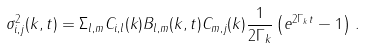<formula> <loc_0><loc_0><loc_500><loc_500>\sigma ^ { 2 } _ { i , j } ( k , t ) = \Sigma _ { l , m } C _ { i , l } ( k ) B _ { l , m } ( { k } , t ) C _ { m , j } ( k ) \frac { 1 } { 2 \Gamma _ { k } } \left ( e ^ { 2 \Gamma _ { k } t } - 1 \right ) \, .</formula> 